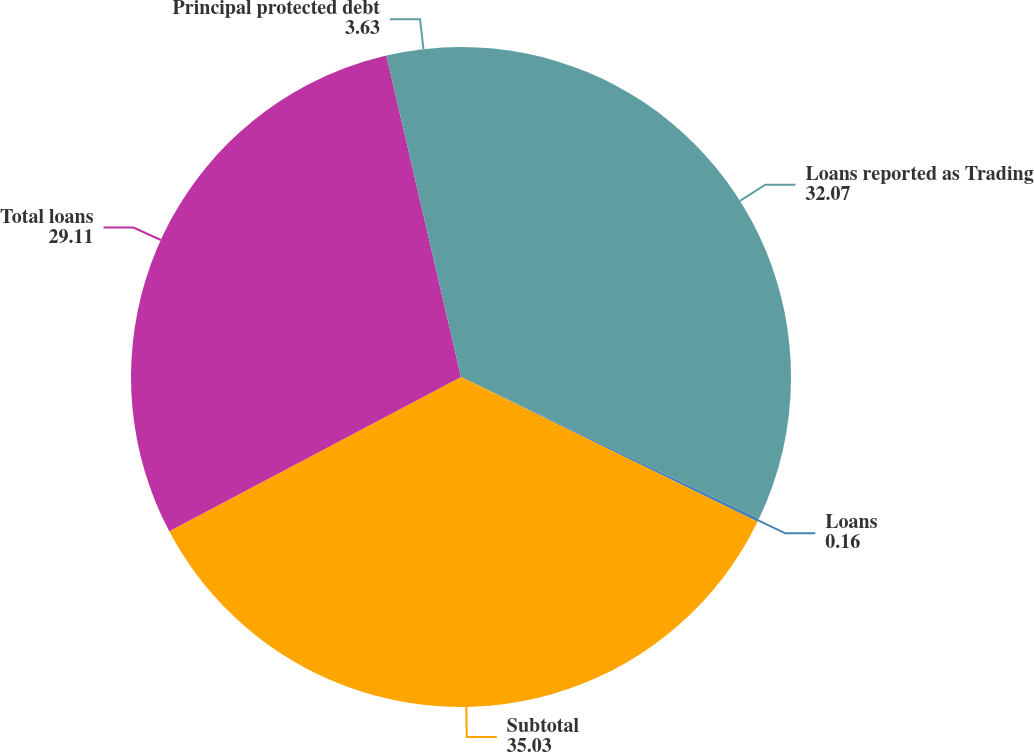<chart> <loc_0><loc_0><loc_500><loc_500><pie_chart><fcel>Loans reported as Trading<fcel>Loans<fcel>Subtotal<fcel>Total loans<fcel>Principal protected debt<nl><fcel>32.07%<fcel>0.16%<fcel>35.03%<fcel>29.11%<fcel>3.63%<nl></chart> 